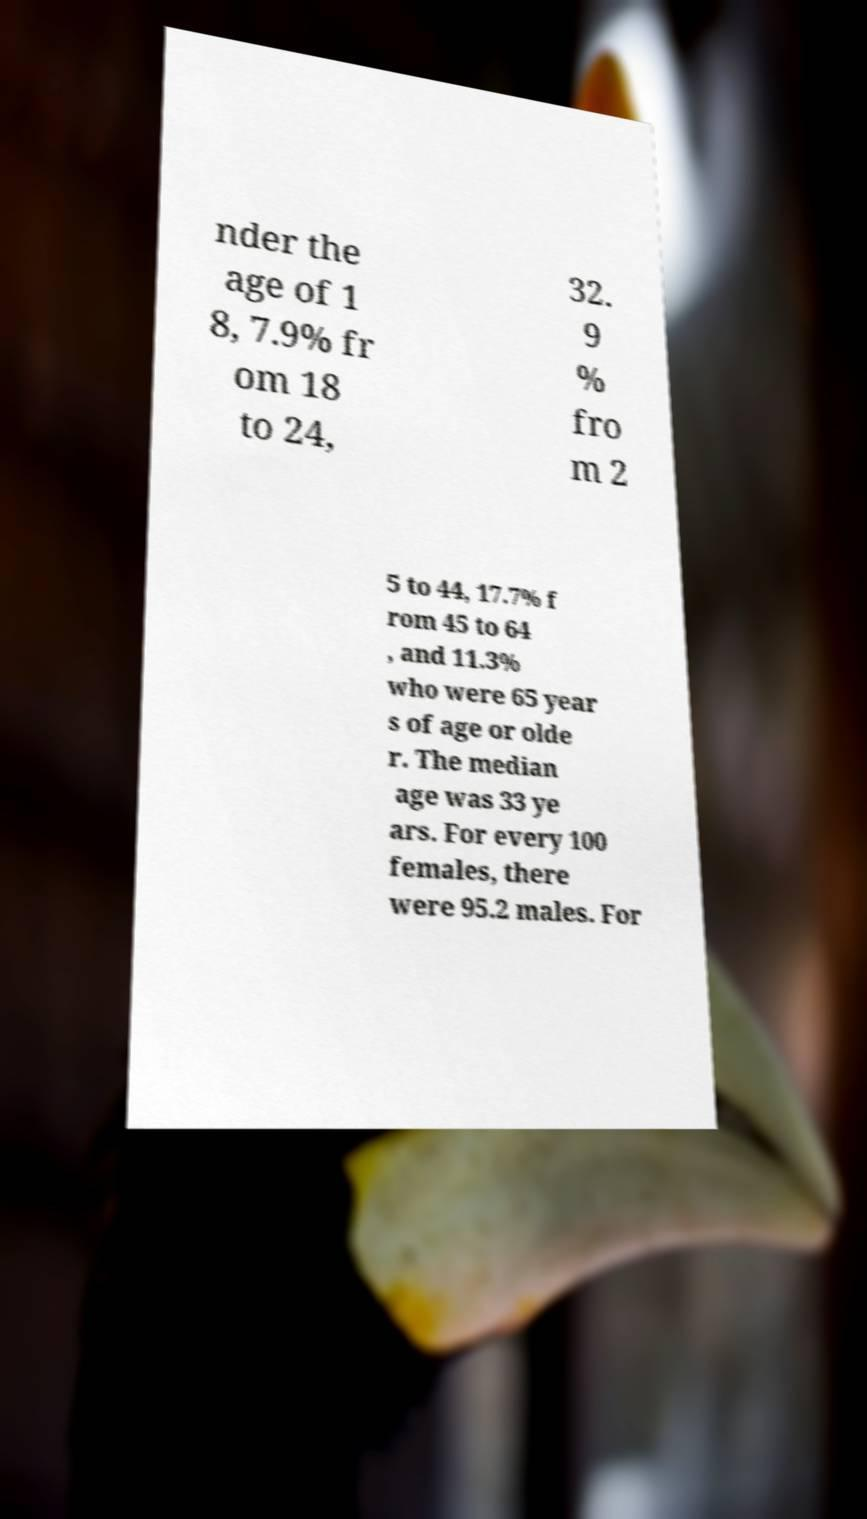Can you accurately transcribe the text from the provided image for me? nder the age of 1 8, 7.9% fr om 18 to 24, 32. 9 % fro m 2 5 to 44, 17.7% f rom 45 to 64 , and 11.3% who were 65 year s of age or olde r. The median age was 33 ye ars. For every 100 females, there were 95.2 males. For 